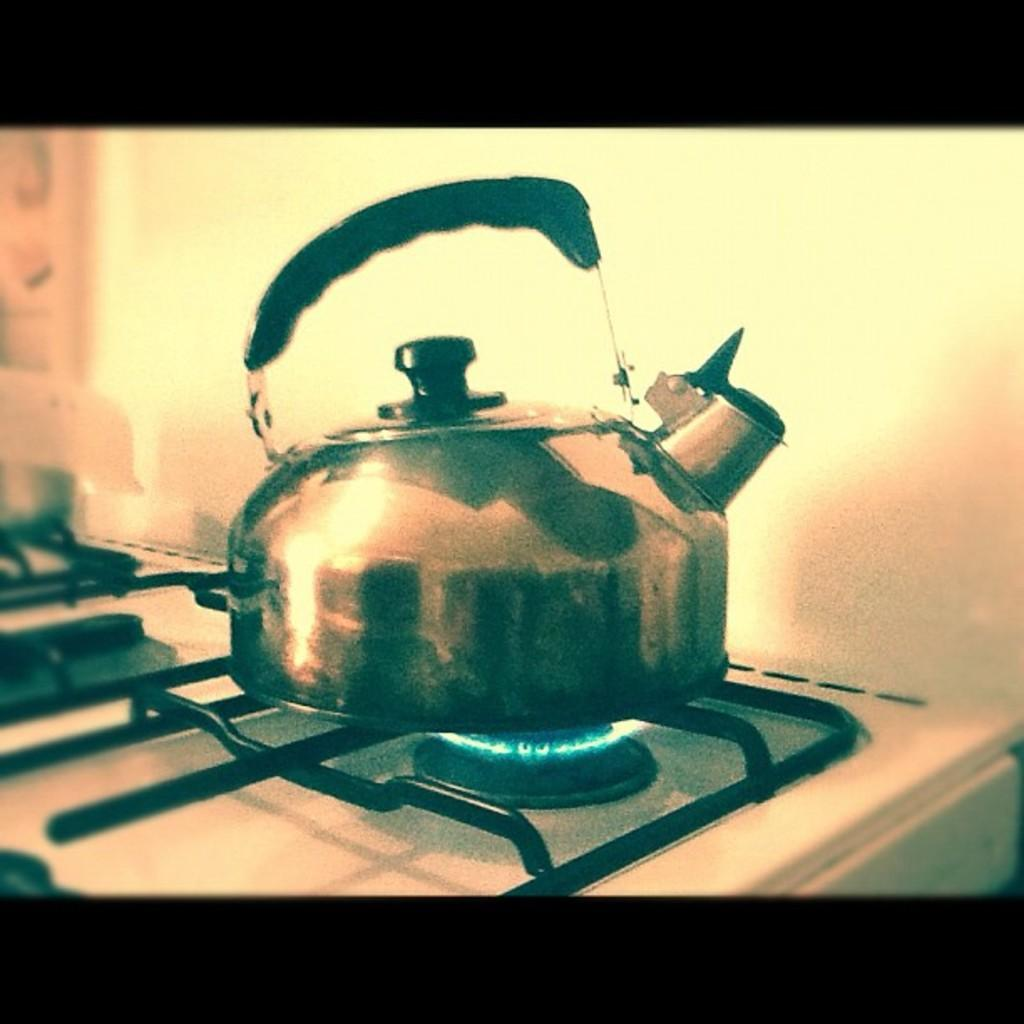What is the main object in the image? There is a stainless tea kettle in the image. Where is the tea kettle located? The tea kettle is placed on a stove. What can be seen in the background of the image? There is a white wall visible in the background of the image. How many lizards are crawling on the tea kettle in the image? There are no lizards present in the image; it only features a stainless tea kettle on a stove. What invention is being used to shape the tea kettle in the image? The image does not show any specific invention being used to shape the tea kettle; it is a standard stainless tea kettle. 